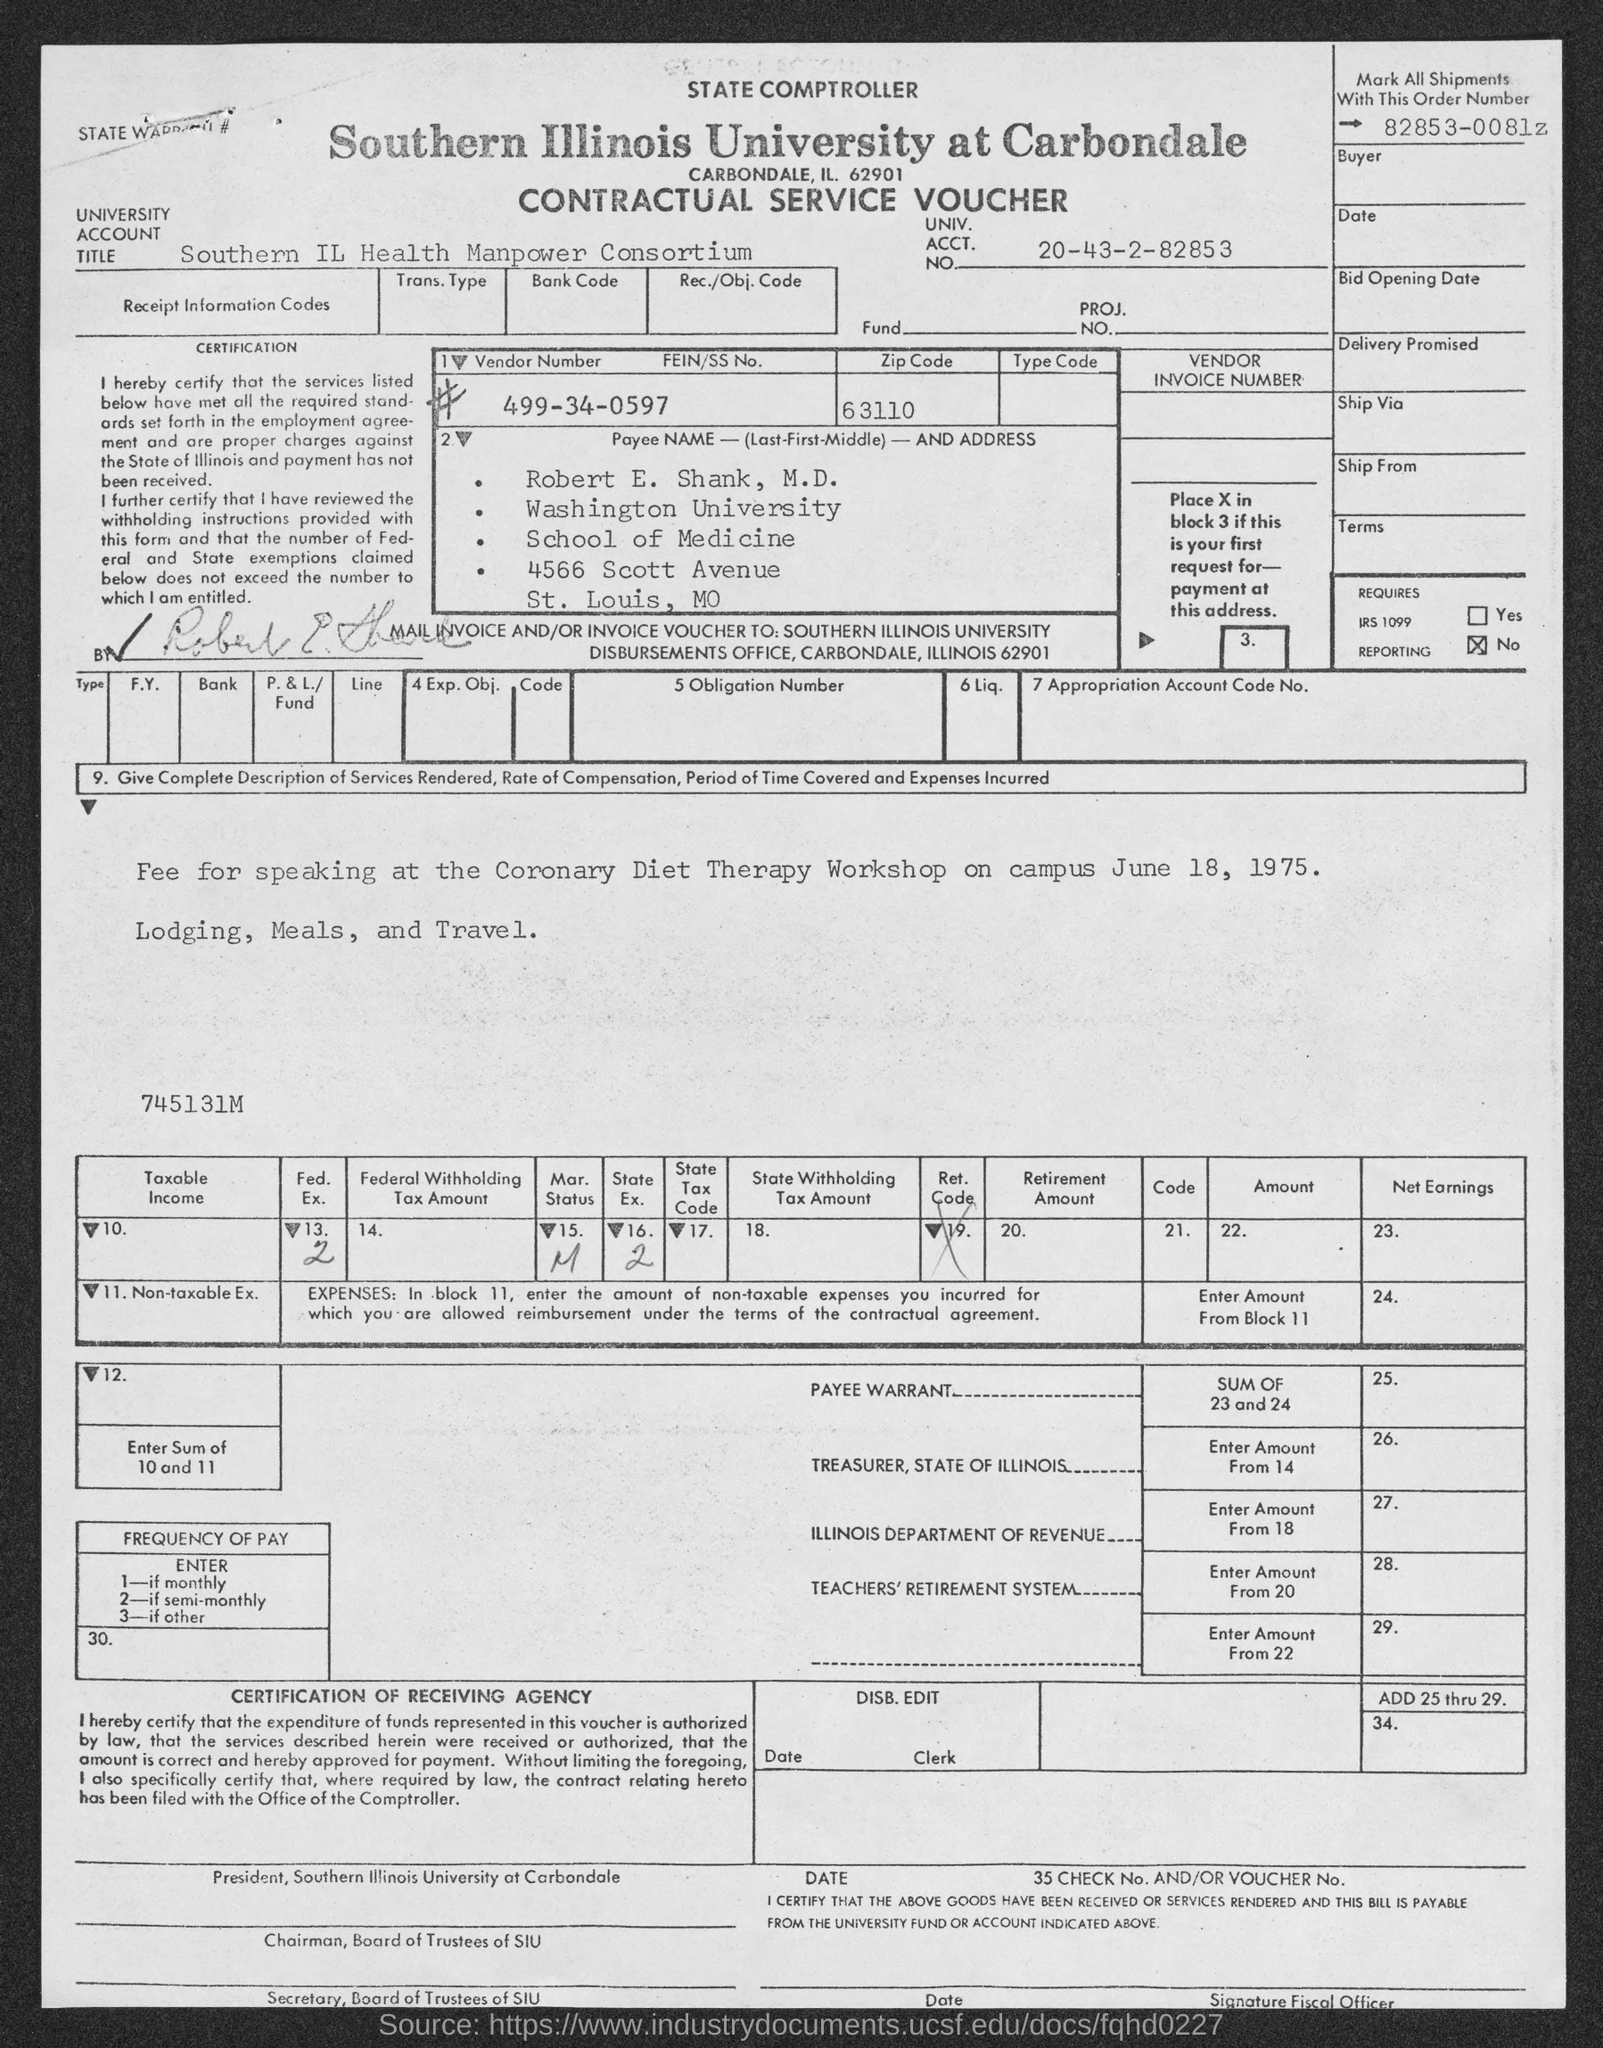What kind of voucher is this?
Offer a terse response. Contractual Service Voucher. What is the University Account Title given in the voucher?
Keep it short and to the point. Southern IL Health Manpower Consortium. What is the UNIV. ACCT. NO. mentioned in the voucher?
Provide a succinct answer. 20-43-2-82853. What is the Payee name given in the voucher?
Ensure brevity in your answer.  Robert E. Shank, M.D. What is the Zip Code mentioned in the voucher?
Provide a succinct answer. 63110. What is the Vendor Number given in the voucher?
Give a very brief answer. 499-34-0597. What is the Order Number used to mark all shipments?
Your answer should be compact. 82853-0081z. 